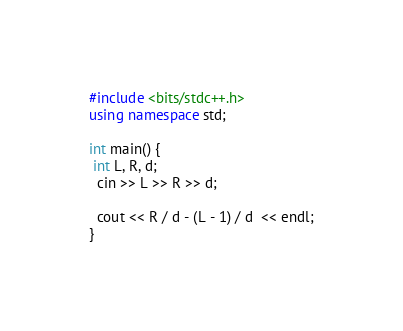Convert code to text. <code><loc_0><loc_0><loc_500><loc_500><_C++_>#include <bits/stdc++.h>
using namespace std;

int main() {
 int L, R, d;
  cin >> L >> R >> d;
  
  cout << R / d - (L - 1) / d  << endl;
}</code> 